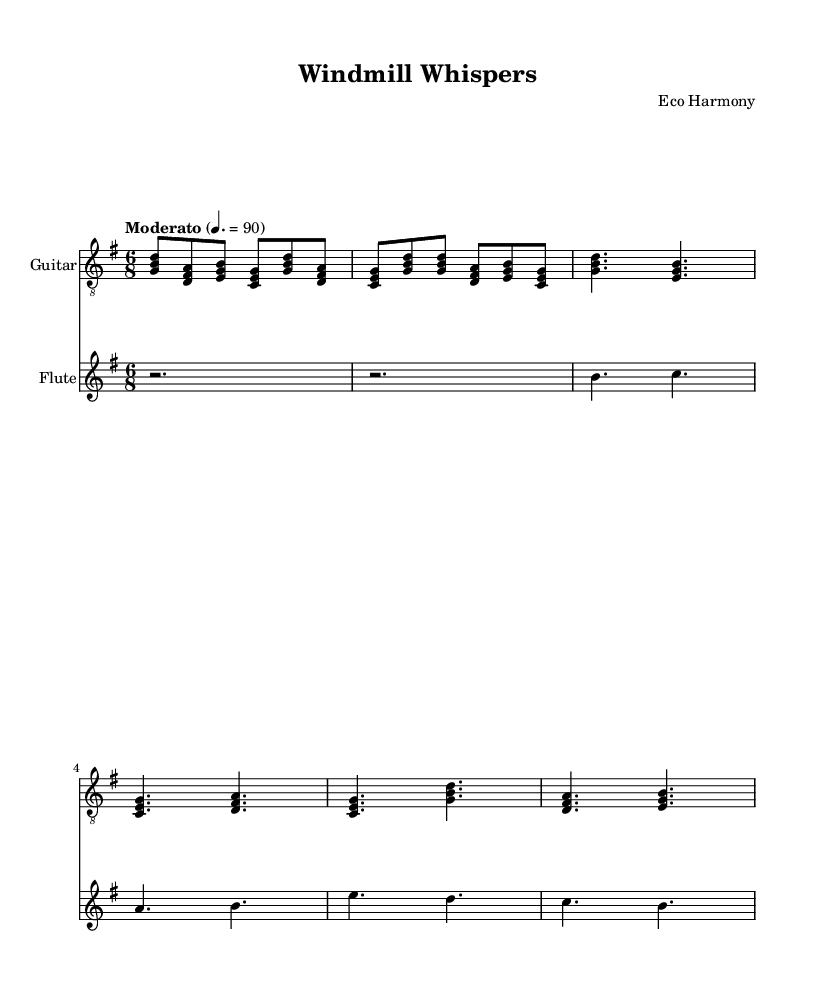What is the key signature of this music? The key signature is indicated by the "g" symbol at the beginning of the piece, showing that it is G major, which has one sharp (F#).
Answer: G major What is the time signature of this music? The time signature is represented by "6/8" shown next to the key signature, indicating there are six eighth notes in each measure.
Answer: 6/8 What is the tempo marking of this music? The tempo marking is provided as "Moderato" with a metronome marking of "4. = 90", suggesting a moderate speed of 90 beats per minute.
Answer: Moderato How many measures are there in the guitar part? Counting the sequences of notes and the bar lines in the guitar part indicates there are a total of 10 measures present in the section shown.
Answer: 10 What is the primary instrument used in the fusion of this piece? The primary instrument, as indicated in the scores, is the guitar, being the first instrument listed and having a distinct part throughout the piece.
Answer: Guitar What genre does this music belong to based on its title and structure? The title "Windmill Whispers" and the fusion of traditional elements like flute and guitar with experimental sounds reflect an Experimental folk fusion genre.
Answer: Experimental folk fusion What type of instruments are used in the score? The score includes a guitar and a flute, which are both common in folk music and contribute to the experimental sound of the piece.
Answer: Guitar and flute 